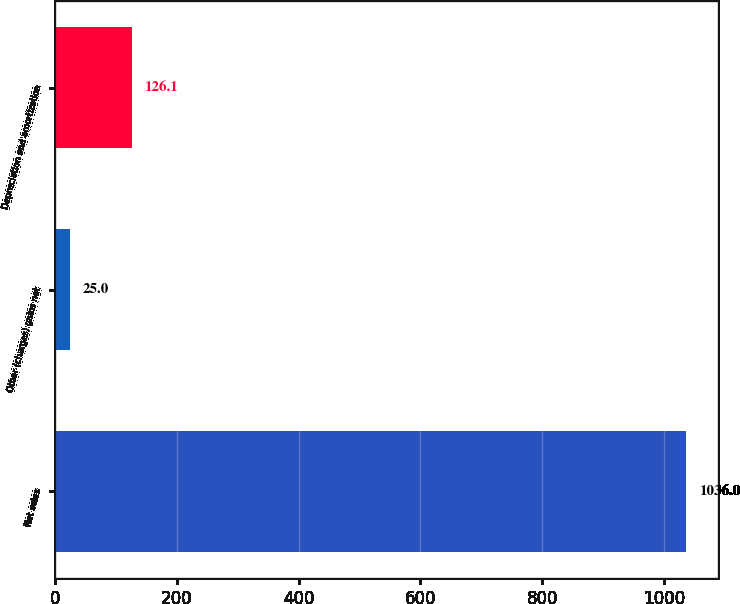<chart> <loc_0><loc_0><loc_500><loc_500><bar_chart><fcel>Net sales<fcel>Other (charges) gains net<fcel>Depreciation and amortization<nl><fcel>1036<fcel>25<fcel>126.1<nl></chart> 